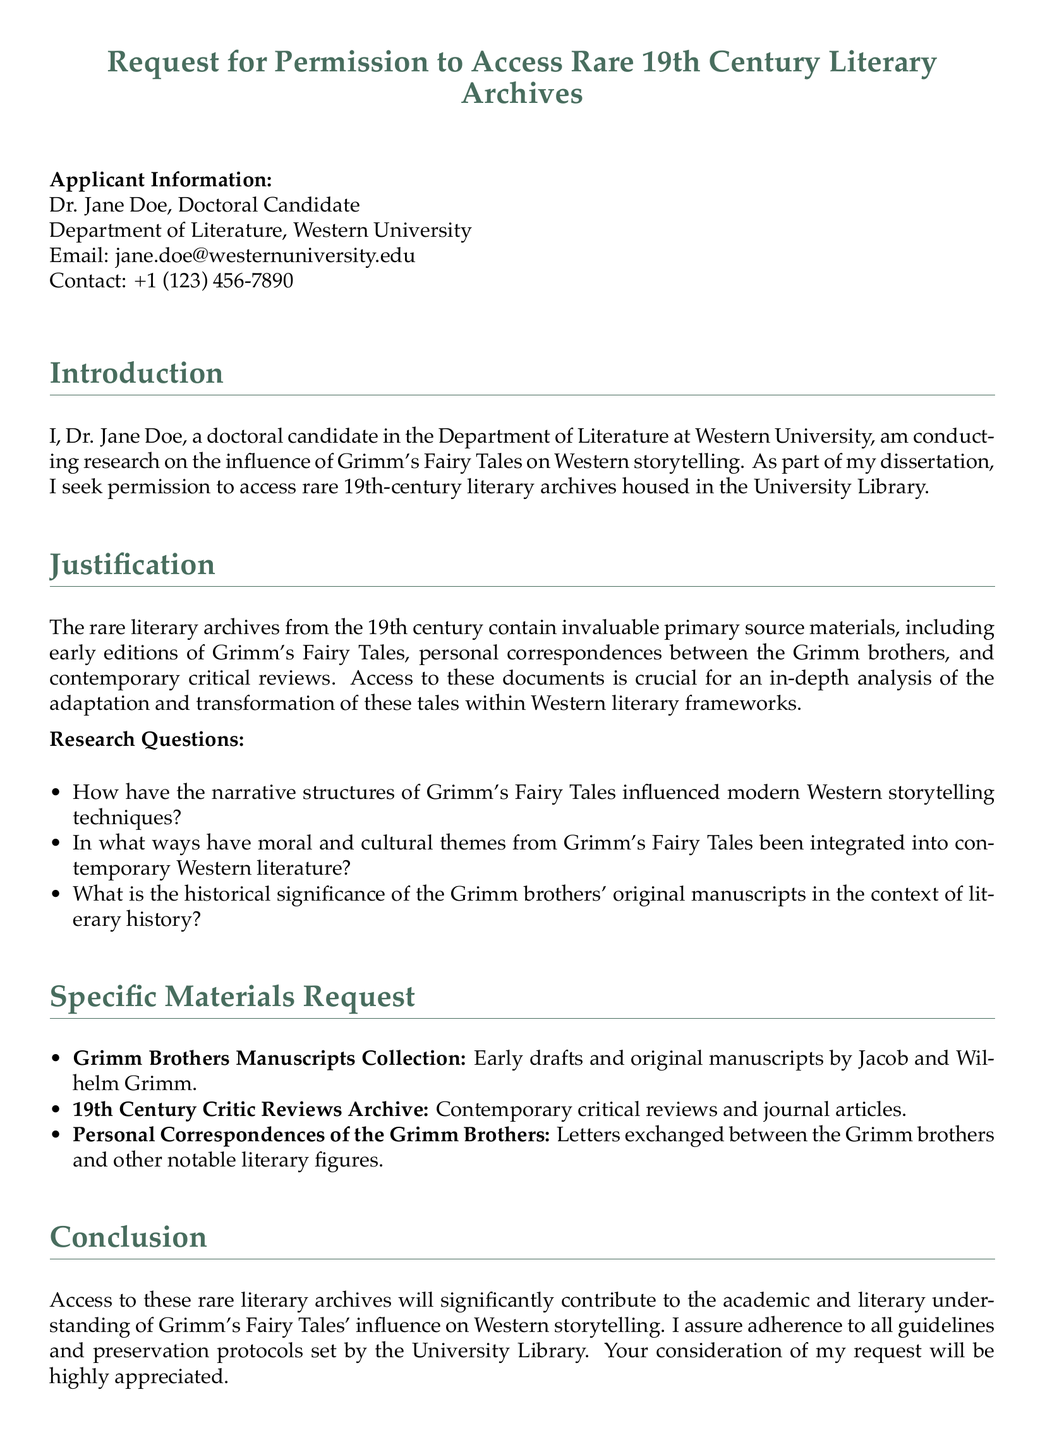What is the applicant's name? The applicant's name is stated at the beginning of the document as Dr. Jane Doe.
Answer: Dr. Jane Doe What is the contact email provided? The document lists the applicant's email address as part of the contact information.
Answer: jane.doe@westernuniversity.edu What is the date of the request? The date is mentioned at the bottom of the document where the applicant signs.
Answer: October 10, 2023 What department does the applicant belong to? The document specifies the department in which the applicant is enrolled.
Answer: Department of Literature What are the first two research questions listed? The document states the research questions explicitly, requiring the first two for this answer.
Answer: How have the narrative structures of Grimm's Fairy Tales influenced modern Western storytelling techniques? In what ways have moral and cultural themes from Grimm's Fairy Tales been integrated into contemporary Western literature? What specific materials are requested? The document lists various materials requested for access, referring specifically to three collections.
Answer: Grimm Brothers Manuscripts Collection, 19th Century Critic Reviews Archive, Personal Correspondences of the Grimm Brothers What is the purpose of accessing the archives? The justification section outlines the purpose, which encompasses broader academic objectives.
Answer: Influence of Grimm's Fairy Tales on Western storytelling What is the main topic of the research? The title and introductory paragraph highlight the overarching theme of the research conducted by the applicant.
Answer: Influence of Grimm's Fairy Tales on Western storytelling How many specific materials are listed in the document? The specific materials requested are enumerated, and counting them provides this answer.
Answer: Three 